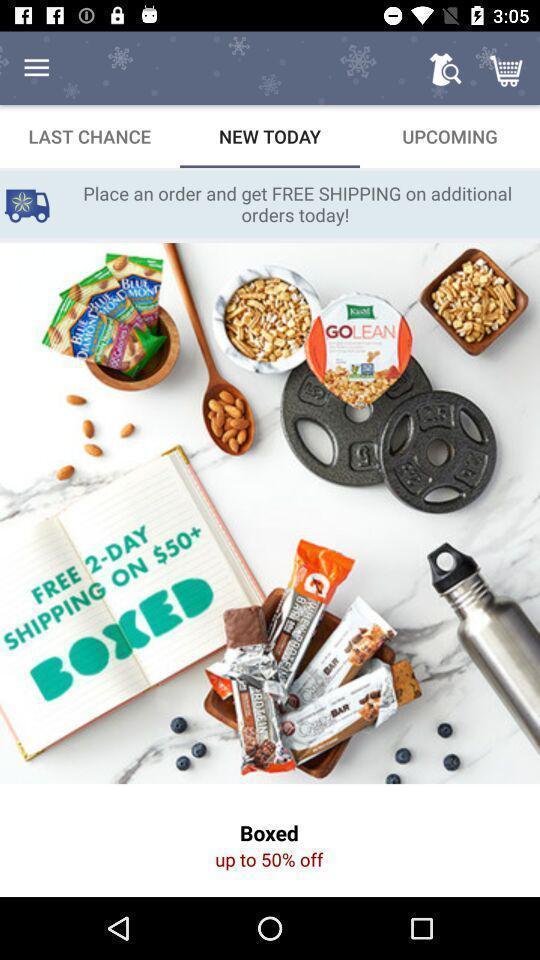Provide a textual representation of this image. Screen displaying the new offer for the day. 